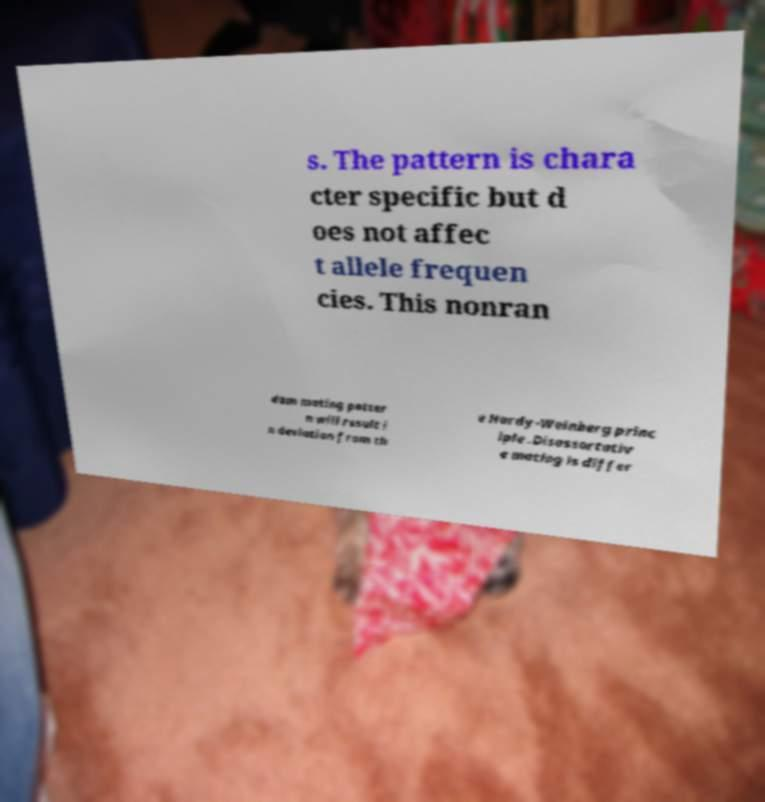What messages or text are displayed in this image? I need them in a readable, typed format. s. The pattern is chara cter specific but d oes not affec t allele frequen cies. This nonran dom mating patter n will result i n deviation from th e Hardy-Weinberg princ iple .Disassortativ e mating is differ 